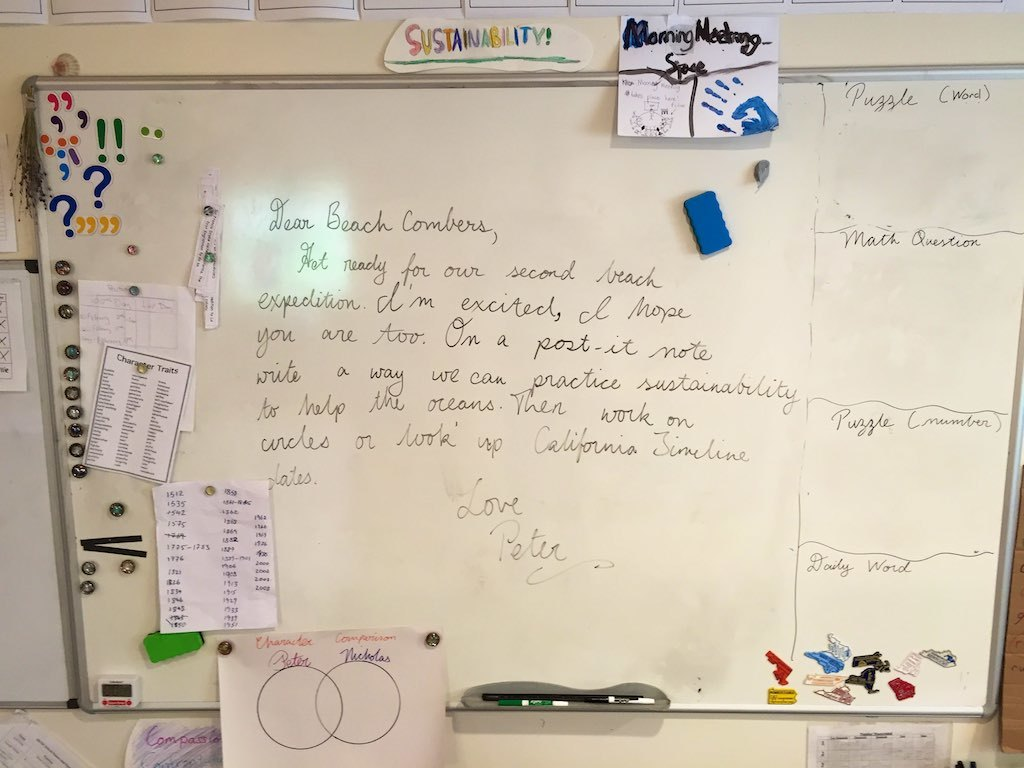How might the 'Morning Message' section of the board be used by the team? The 'Morning Message' section likely serves as a daily bulletin for the team, where motivational quotes or important updates are shared to foster a positive start to the day. This feature reflects a thoughtful approach to workplace morale and communication, ensuring that all team members are aligned and engaged from the moment they step into the office. 